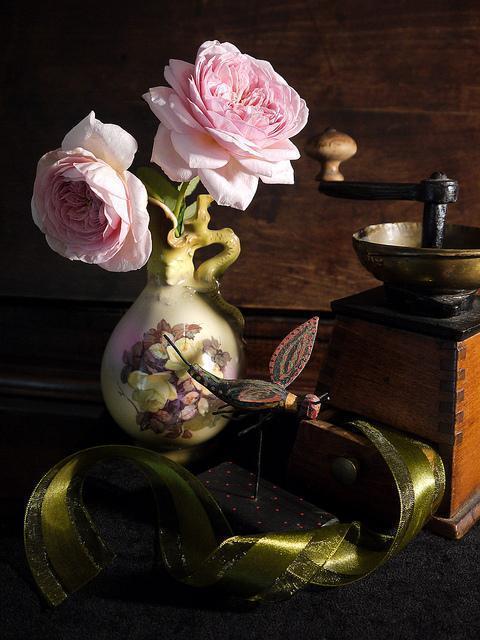How many flowers are on the counter?
Give a very brief answer. 2. How many people are wearing a blue dress?
Give a very brief answer. 0. 